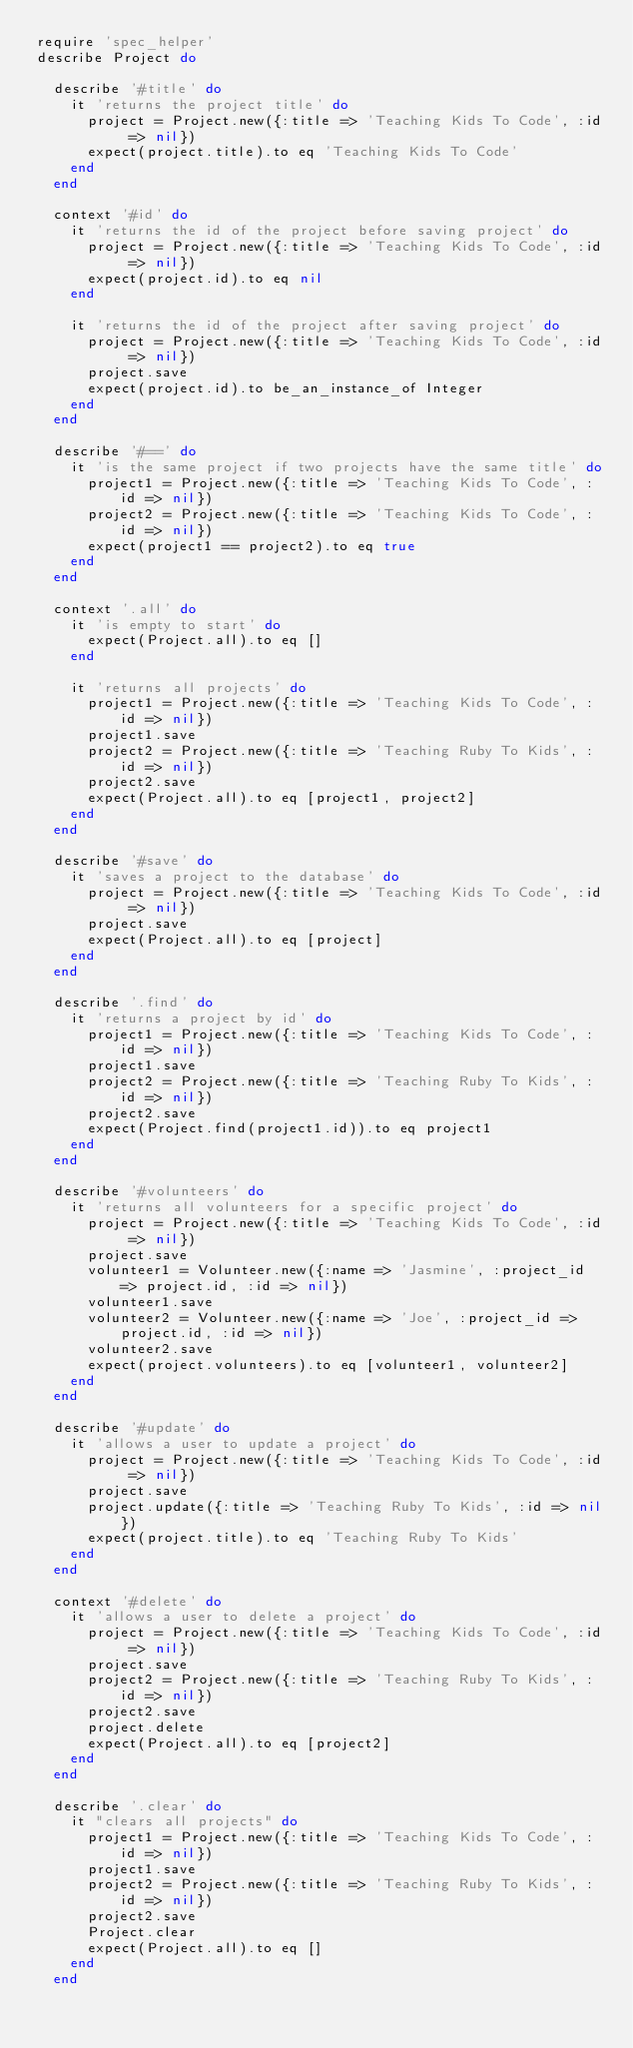<code> <loc_0><loc_0><loc_500><loc_500><_Ruby_>require 'spec_helper'
describe Project do

  describe '#title' do
    it 'returns the project title' do
      project = Project.new({:title => 'Teaching Kids To Code', :id => nil})
      expect(project.title).to eq 'Teaching Kids To Code'
    end
  end

  context '#id' do
    it 'returns the id of the project before saving project' do
      project = Project.new({:title => 'Teaching Kids To Code', :id => nil})
      expect(project.id).to eq nil
    end

    it 'returns the id of the project after saving project' do
      project = Project.new({:title => 'Teaching Kids To Code', :id => nil})
      project.save
      expect(project.id).to be_an_instance_of Integer
    end
  end

  describe '#==' do
    it 'is the same project if two projects have the same title' do
      project1 = Project.new({:title => 'Teaching Kids To Code', :id => nil})
      project2 = Project.new({:title => 'Teaching Kids To Code', :id => nil})
      expect(project1 == project2).to eq true
    end
  end

  context '.all' do
    it 'is empty to start' do
      expect(Project.all).to eq []
    end

    it 'returns all projects' do
      project1 = Project.new({:title => 'Teaching Kids To Code', :id => nil})
      project1.save
      project2 = Project.new({:title => 'Teaching Ruby To Kids', :id => nil})
      project2.save
      expect(Project.all).to eq [project1, project2]
    end
  end

  describe '#save' do
    it 'saves a project to the database' do
      project = Project.new({:title => 'Teaching Kids To Code', :id => nil})
      project.save
      expect(Project.all).to eq [project]
    end
  end

  describe '.find' do
    it 'returns a project by id' do
      project1 = Project.new({:title => 'Teaching Kids To Code', :id => nil})
      project1.save
      project2 = Project.new({:title => 'Teaching Ruby To Kids', :id => nil})
      project2.save
      expect(Project.find(project1.id)).to eq project1
    end
  end

  describe '#volunteers' do
    it 'returns all volunteers for a specific project' do
      project = Project.new({:title => 'Teaching Kids To Code', :id => nil})
      project.save
      volunteer1 = Volunteer.new({:name => 'Jasmine', :project_id => project.id, :id => nil})
      volunteer1.save
      volunteer2 = Volunteer.new({:name => 'Joe', :project_id => project.id, :id => nil})
      volunteer2.save
      expect(project.volunteers).to eq [volunteer1, volunteer2]
    end
  end

  describe '#update' do
    it 'allows a user to update a project' do
      project = Project.new({:title => 'Teaching Kids To Code', :id => nil})
      project.save
      project.update({:title => 'Teaching Ruby To Kids', :id => nil})
      expect(project.title).to eq 'Teaching Ruby To Kids'
    end
  end

  context '#delete' do
    it 'allows a user to delete a project' do
      project = Project.new({:title => 'Teaching Kids To Code', :id => nil})
      project.save
      project2 = Project.new({:title => 'Teaching Ruby To Kids', :id => nil})
      project2.save
      project.delete
      expect(Project.all).to eq [project2]
    end
  end

  describe '.clear' do
    it "clears all projects" do
      project1 = Project.new({:title => 'Teaching Kids To Code', :id => nil})
      project1.save
      project2 = Project.new({:title => 'Teaching Ruby To Kids', :id => nil})
      project2.save
      Project.clear
      expect(Project.all).to eq []
    end
  end
</code> 